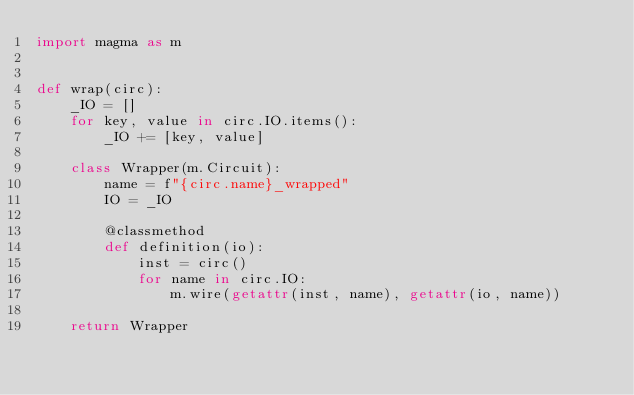<code> <loc_0><loc_0><loc_500><loc_500><_Python_>import magma as m


def wrap(circ):
    _IO = []
    for key, value in circ.IO.items():
        _IO += [key, value]

    class Wrapper(m.Circuit):
        name = f"{circ.name}_wrapped"
        IO = _IO

        @classmethod
        def definition(io):
            inst = circ()
            for name in circ.IO:
                m.wire(getattr(inst, name), getattr(io, name))

    return Wrapper
</code> 